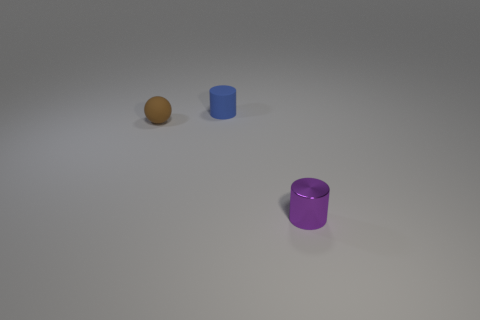Add 1 red matte cubes. How many objects exist? 4 Subtract all spheres. How many objects are left? 2 Subtract all blue rubber objects. Subtract all brown spheres. How many objects are left? 1 Add 1 brown balls. How many brown balls are left? 2 Add 2 yellow metal cylinders. How many yellow metal cylinders exist? 2 Subtract 0 green cylinders. How many objects are left? 3 